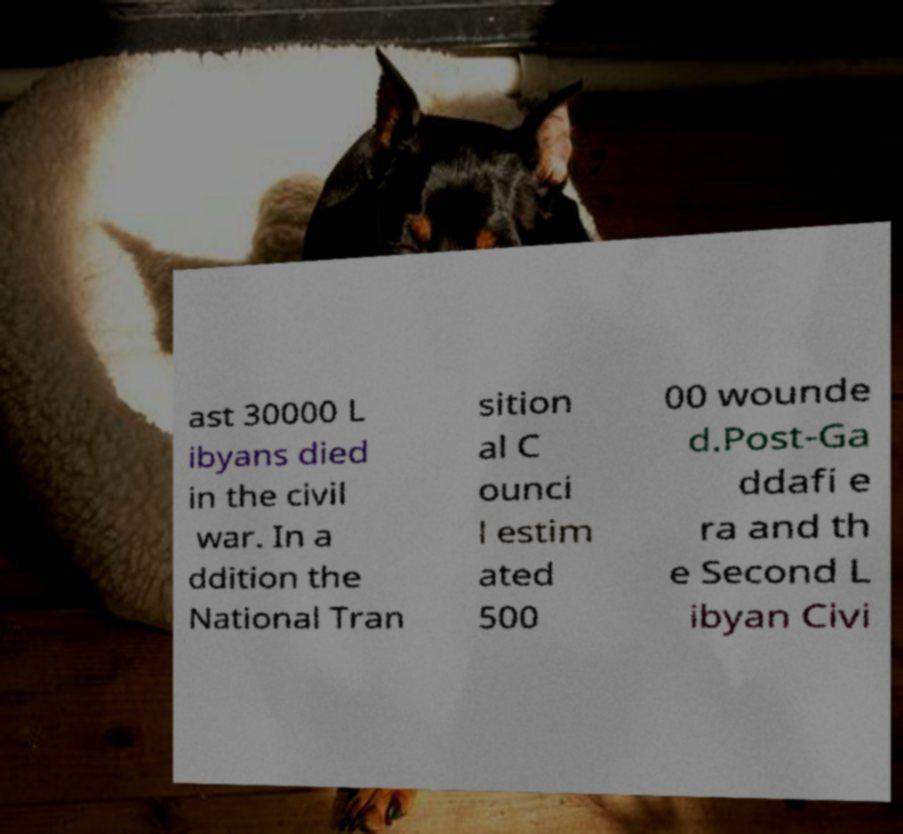I need the written content from this picture converted into text. Can you do that? ast 30000 L ibyans died in the civil war. In a ddition the National Tran sition al C ounci l estim ated 500 00 wounde d.Post-Ga ddafi e ra and th e Second L ibyan Civi 